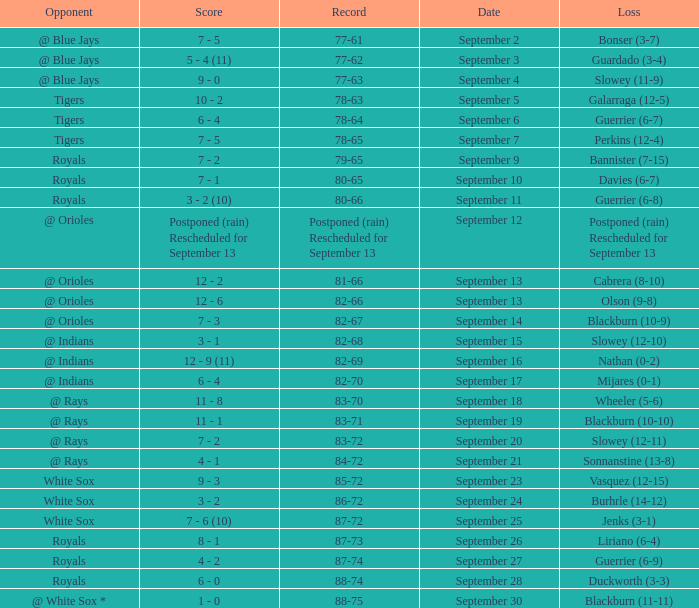What score has the opponent of tigers and a record of 78-64? 6 - 4. 